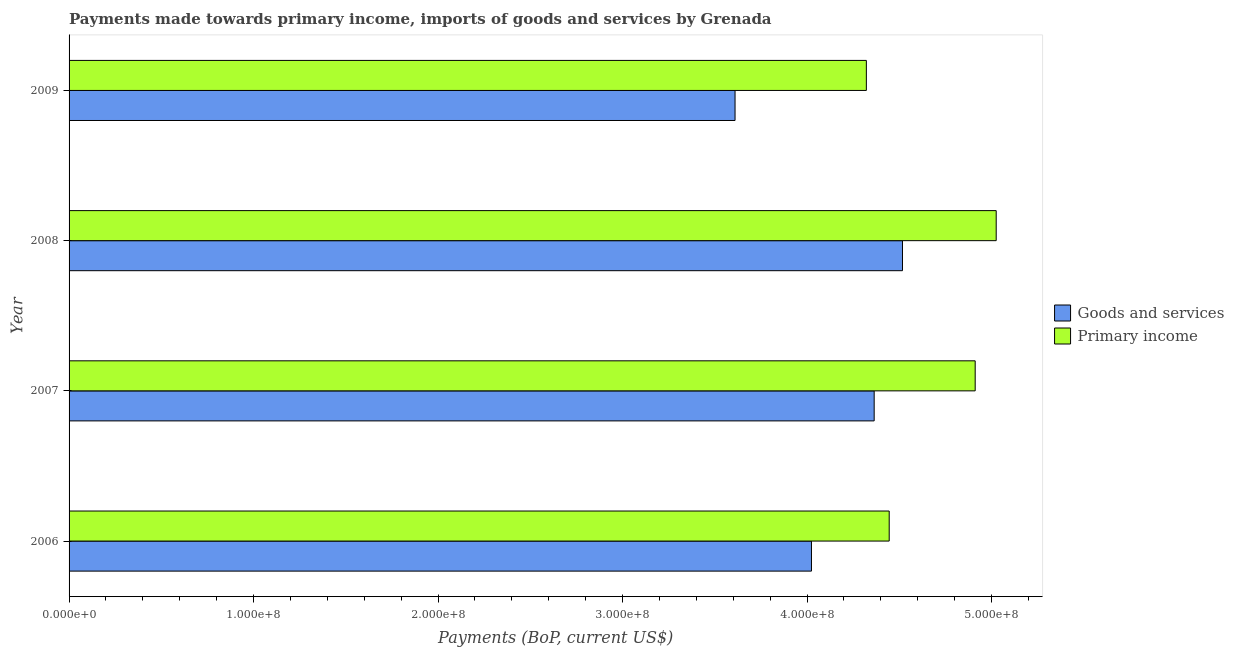How many groups of bars are there?
Ensure brevity in your answer.  4. Are the number of bars on each tick of the Y-axis equal?
Provide a short and direct response. Yes. What is the payments made towards goods and services in 2008?
Offer a terse response. 4.52e+08. Across all years, what is the maximum payments made towards primary income?
Provide a short and direct response. 5.03e+08. Across all years, what is the minimum payments made towards primary income?
Provide a short and direct response. 4.32e+08. In which year was the payments made towards primary income minimum?
Your answer should be very brief. 2009. What is the total payments made towards primary income in the graph?
Keep it short and to the point. 1.87e+09. What is the difference between the payments made towards primary income in 2006 and that in 2007?
Offer a terse response. -4.66e+07. What is the difference between the payments made towards primary income in 2009 and the payments made towards goods and services in 2008?
Your response must be concise. -1.96e+07. What is the average payments made towards primary income per year?
Offer a terse response. 4.68e+08. In the year 2009, what is the difference between the payments made towards primary income and payments made towards goods and services?
Ensure brevity in your answer.  7.12e+07. What is the ratio of the payments made towards goods and services in 2006 to that in 2009?
Give a very brief answer. 1.11. Is the difference between the payments made towards primary income in 2007 and 2009 greater than the difference between the payments made towards goods and services in 2007 and 2009?
Give a very brief answer. No. What is the difference between the highest and the second highest payments made towards primary income?
Your answer should be compact. 1.14e+07. What is the difference between the highest and the lowest payments made towards goods and services?
Your answer should be very brief. 9.08e+07. What does the 2nd bar from the top in 2009 represents?
Offer a very short reply. Goods and services. What does the 1st bar from the bottom in 2007 represents?
Keep it short and to the point. Goods and services. Are all the bars in the graph horizontal?
Make the answer very short. Yes. What is the difference between two consecutive major ticks on the X-axis?
Your answer should be compact. 1.00e+08. Does the graph contain any zero values?
Provide a short and direct response. No. Does the graph contain grids?
Provide a succinct answer. No. What is the title of the graph?
Your answer should be compact. Payments made towards primary income, imports of goods and services by Grenada. What is the label or title of the X-axis?
Your response must be concise. Payments (BoP, current US$). What is the Payments (BoP, current US$) of Goods and services in 2006?
Offer a very short reply. 4.02e+08. What is the Payments (BoP, current US$) in Primary income in 2006?
Your response must be concise. 4.45e+08. What is the Payments (BoP, current US$) of Goods and services in 2007?
Make the answer very short. 4.36e+08. What is the Payments (BoP, current US$) in Primary income in 2007?
Provide a short and direct response. 4.91e+08. What is the Payments (BoP, current US$) of Goods and services in 2008?
Your answer should be very brief. 4.52e+08. What is the Payments (BoP, current US$) in Primary income in 2008?
Your answer should be compact. 5.03e+08. What is the Payments (BoP, current US$) in Goods and services in 2009?
Offer a very short reply. 3.61e+08. What is the Payments (BoP, current US$) of Primary income in 2009?
Your answer should be compact. 4.32e+08. Across all years, what is the maximum Payments (BoP, current US$) of Goods and services?
Ensure brevity in your answer.  4.52e+08. Across all years, what is the maximum Payments (BoP, current US$) in Primary income?
Ensure brevity in your answer.  5.03e+08. Across all years, what is the minimum Payments (BoP, current US$) of Goods and services?
Your answer should be very brief. 3.61e+08. Across all years, what is the minimum Payments (BoP, current US$) in Primary income?
Your answer should be very brief. 4.32e+08. What is the total Payments (BoP, current US$) in Goods and services in the graph?
Keep it short and to the point. 1.65e+09. What is the total Payments (BoP, current US$) of Primary income in the graph?
Offer a very short reply. 1.87e+09. What is the difference between the Payments (BoP, current US$) in Goods and services in 2006 and that in 2007?
Offer a very short reply. -3.40e+07. What is the difference between the Payments (BoP, current US$) in Primary income in 2006 and that in 2007?
Your answer should be compact. -4.66e+07. What is the difference between the Payments (BoP, current US$) of Goods and services in 2006 and that in 2008?
Offer a terse response. -4.93e+07. What is the difference between the Payments (BoP, current US$) in Primary income in 2006 and that in 2008?
Keep it short and to the point. -5.80e+07. What is the difference between the Payments (BoP, current US$) in Goods and services in 2006 and that in 2009?
Offer a very short reply. 4.14e+07. What is the difference between the Payments (BoP, current US$) of Primary income in 2006 and that in 2009?
Your answer should be compact. 1.24e+07. What is the difference between the Payments (BoP, current US$) in Goods and services in 2007 and that in 2008?
Keep it short and to the point. -1.53e+07. What is the difference between the Payments (BoP, current US$) in Primary income in 2007 and that in 2008?
Your answer should be compact. -1.14e+07. What is the difference between the Payments (BoP, current US$) of Goods and services in 2007 and that in 2009?
Offer a very short reply. 7.54e+07. What is the difference between the Payments (BoP, current US$) in Primary income in 2007 and that in 2009?
Offer a terse response. 5.90e+07. What is the difference between the Payments (BoP, current US$) in Goods and services in 2008 and that in 2009?
Your answer should be compact. 9.08e+07. What is the difference between the Payments (BoP, current US$) of Primary income in 2008 and that in 2009?
Your answer should be compact. 7.04e+07. What is the difference between the Payments (BoP, current US$) of Goods and services in 2006 and the Payments (BoP, current US$) of Primary income in 2007?
Your answer should be compact. -8.87e+07. What is the difference between the Payments (BoP, current US$) in Goods and services in 2006 and the Payments (BoP, current US$) in Primary income in 2008?
Ensure brevity in your answer.  -1.00e+08. What is the difference between the Payments (BoP, current US$) in Goods and services in 2006 and the Payments (BoP, current US$) in Primary income in 2009?
Ensure brevity in your answer.  -2.98e+07. What is the difference between the Payments (BoP, current US$) of Goods and services in 2007 and the Payments (BoP, current US$) of Primary income in 2008?
Your response must be concise. -6.61e+07. What is the difference between the Payments (BoP, current US$) of Goods and services in 2007 and the Payments (BoP, current US$) of Primary income in 2009?
Offer a very short reply. 4.24e+06. What is the difference between the Payments (BoP, current US$) of Goods and services in 2008 and the Payments (BoP, current US$) of Primary income in 2009?
Your response must be concise. 1.96e+07. What is the average Payments (BoP, current US$) in Goods and services per year?
Provide a short and direct response. 4.13e+08. What is the average Payments (BoP, current US$) in Primary income per year?
Your response must be concise. 4.68e+08. In the year 2006, what is the difference between the Payments (BoP, current US$) in Goods and services and Payments (BoP, current US$) in Primary income?
Ensure brevity in your answer.  -4.21e+07. In the year 2007, what is the difference between the Payments (BoP, current US$) of Goods and services and Payments (BoP, current US$) of Primary income?
Your answer should be compact. -5.48e+07. In the year 2008, what is the difference between the Payments (BoP, current US$) in Goods and services and Payments (BoP, current US$) in Primary income?
Offer a terse response. -5.08e+07. In the year 2009, what is the difference between the Payments (BoP, current US$) of Goods and services and Payments (BoP, current US$) of Primary income?
Offer a very short reply. -7.12e+07. What is the ratio of the Payments (BoP, current US$) of Goods and services in 2006 to that in 2007?
Ensure brevity in your answer.  0.92. What is the ratio of the Payments (BoP, current US$) in Primary income in 2006 to that in 2007?
Make the answer very short. 0.91. What is the ratio of the Payments (BoP, current US$) in Goods and services in 2006 to that in 2008?
Make the answer very short. 0.89. What is the ratio of the Payments (BoP, current US$) of Primary income in 2006 to that in 2008?
Offer a very short reply. 0.88. What is the ratio of the Payments (BoP, current US$) of Goods and services in 2006 to that in 2009?
Provide a succinct answer. 1.11. What is the ratio of the Payments (BoP, current US$) in Primary income in 2006 to that in 2009?
Your answer should be compact. 1.03. What is the ratio of the Payments (BoP, current US$) in Goods and services in 2007 to that in 2008?
Ensure brevity in your answer.  0.97. What is the ratio of the Payments (BoP, current US$) in Primary income in 2007 to that in 2008?
Make the answer very short. 0.98. What is the ratio of the Payments (BoP, current US$) of Goods and services in 2007 to that in 2009?
Ensure brevity in your answer.  1.21. What is the ratio of the Payments (BoP, current US$) in Primary income in 2007 to that in 2009?
Your response must be concise. 1.14. What is the ratio of the Payments (BoP, current US$) of Goods and services in 2008 to that in 2009?
Your response must be concise. 1.25. What is the ratio of the Payments (BoP, current US$) in Primary income in 2008 to that in 2009?
Offer a terse response. 1.16. What is the difference between the highest and the second highest Payments (BoP, current US$) of Goods and services?
Make the answer very short. 1.53e+07. What is the difference between the highest and the second highest Payments (BoP, current US$) in Primary income?
Ensure brevity in your answer.  1.14e+07. What is the difference between the highest and the lowest Payments (BoP, current US$) in Goods and services?
Provide a short and direct response. 9.08e+07. What is the difference between the highest and the lowest Payments (BoP, current US$) in Primary income?
Provide a succinct answer. 7.04e+07. 